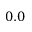Convert formula to latex. <formula><loc_0><loc_0><loc_500><loc_500>0 . 0</formula> 